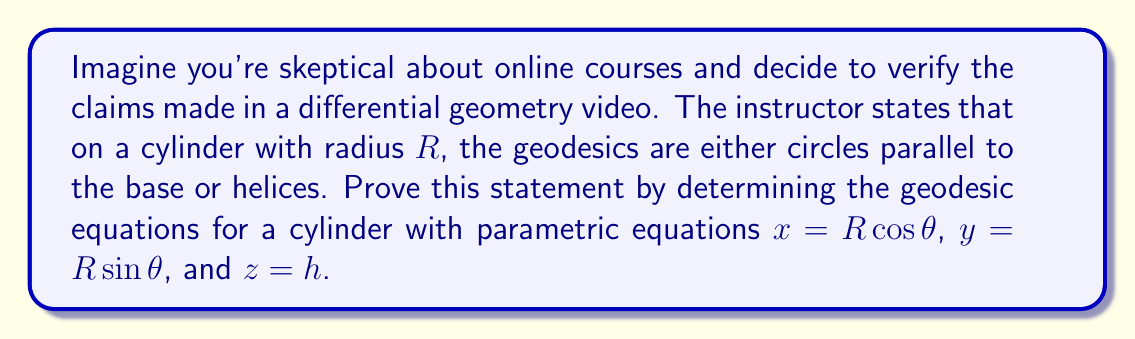Teach me how to tackle this problem. Let's approach this step-by-step:

1) The geodesic equations are given by:

   $$\frac{d^2x^i}{ds^2} + \Gamma^i_{jk}\frac{dx^j}{ds}\frac{dx^k}{ds} = 0$$

   where $\Gamma^i_{jk}$ are the Christoffel symbols.

2) For a cylinder, we can use cylindrical coordinates $(r, \theta, z)$. The metric is:

   $$ds^2 = dr^2 + r^2d\theta^2 + dz^2$$

3) Since $r = R$ is constant on the cylinder, $dr = 0$. The metric simplifies to:

   $$ds^2 = R^2d\theta^2 + dz^2$$

4) The non-zero Christoffel symbols for this metric are:

   $$\Gamma^\theta_{\theta z} = \Gamma^\theta_{z \theta} = \frac{1}{R^2}\frac{\partial R^2}{\partial z} = 0$$
   $$\Gamma^z_{\theta \theta} = -R^2\frac{\partial}{\partial z}\left(\frac{1}{R^2}\right) = 0$$

5) The geodesic equations become:

   $$\frac{d^2\theta}{ds^2} = 0$$
   $$\frac{d^2z}{ds^2} = 0$$

6) Integrating these equations:

   $$\frac{d\theta}{ds} = a \quad \text{(constant)}$$
   $$\frac{dz}{ds} = b \quad \text{(constant)}$$

7) These equations describe two cases:
   
   a) If $a = 0$ and $b \neq 0$, we get circles parallel to the base.
   b) If $a \neq 0$ and $b \neq 0$, we get helices.

Thus, we've proven that the geodesics on a cylinder are indeed circles parallel to the base or helices.
Answer: Geodesics: circles parallel to base ($\frac{d\theta}{ds} = 0$, $\frac{dz}{ds} \neq 0$) or helices ($\frac{d\theta}{ds} \neq 0$, $\frac{dz}{ds} \neq 0$) 